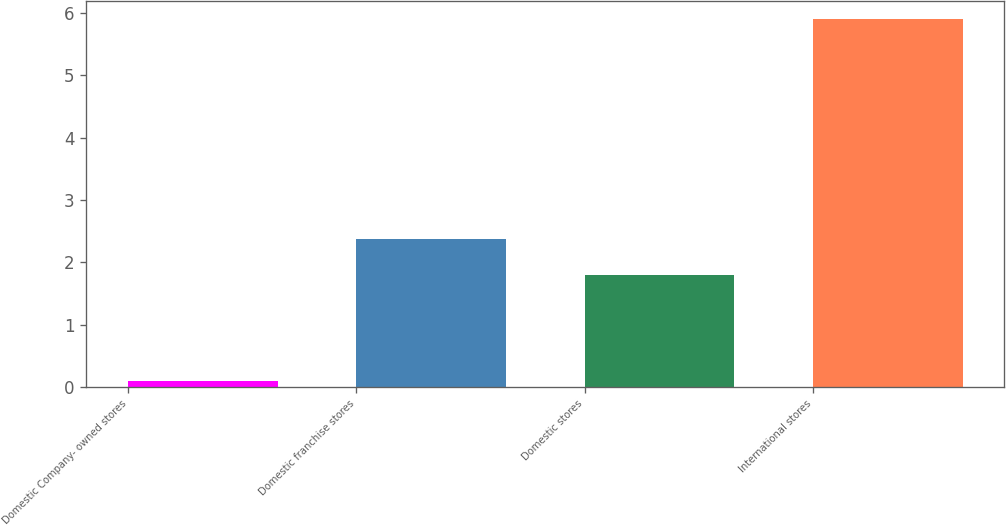Convert chart. <chart><loc_0><loc_0><loc_500><loc_500><bar_chart><fcel>Domestic Company- owned stores<fcel>Domestic franchise stores<fcel>Domestic stores<fcel>International stores<nl><fcel>0.1<fcel>2.38<fcel>1.8<fcel>5.9<nl></chart> 